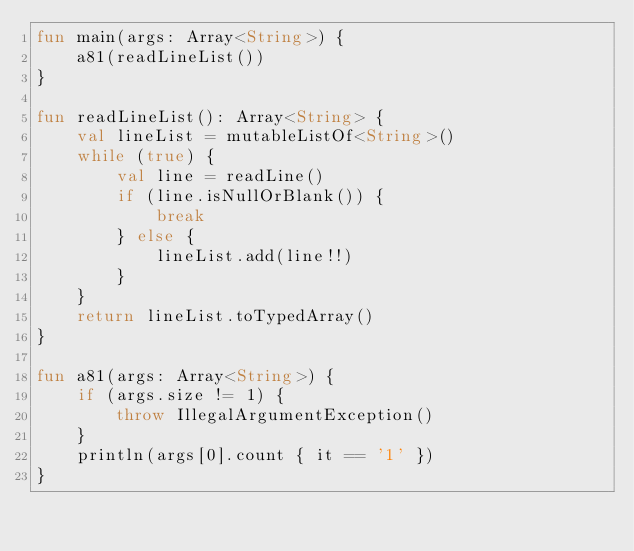<code> <loc_0><loc_0><loc_500><loc_500><_Kotlin_>fun main(args: Array<String>) {
    a81(readLineList())
}

fun readLineList(): Array<String> {
    val lineList = mutableListOf<String>()
    while (true) {
        val line = readLine()
        if (line.isNullOrBlank()) {
            break
        } else {
            lineList.add(line!!)
        }
    }
    return lineList.toTypedArray()
}

fun a81(args: Array<String>) {
    if (args.size != 1) {
        throw IllegalArgumentException()
    }
    println(args[0].count { it == '1' })
}</code> 